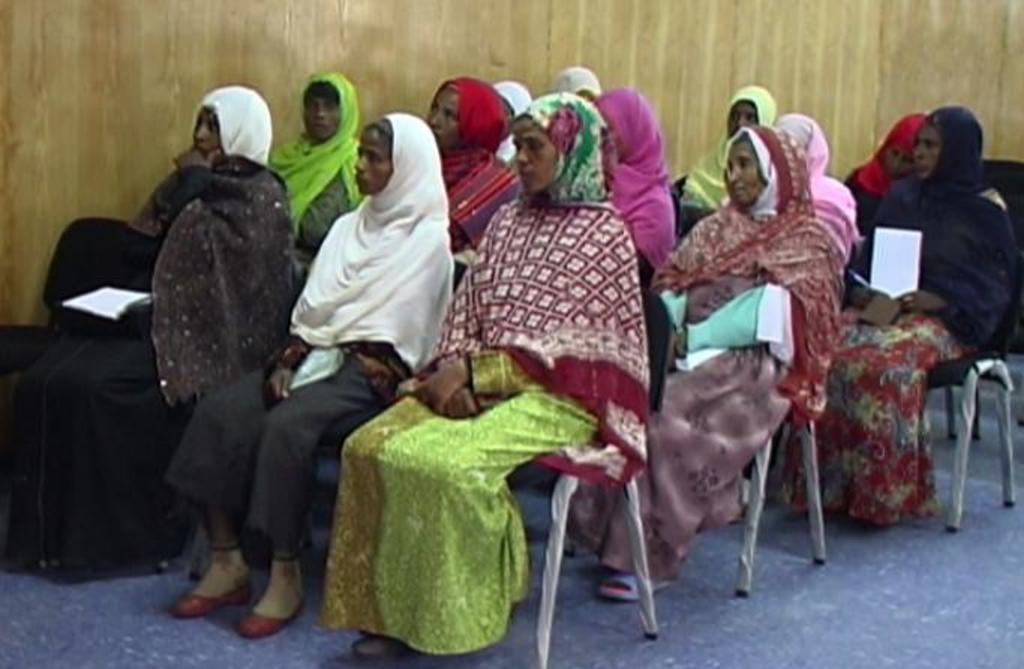Where is the setting of the image? The image is inside a room. What are the people in the image doing? There is a group of people sitting on chairs in the image. What color is the wall in the background of the image? There is a yellow color wall in the background of the image. What type of note is being passed around among the people in the image? There is no note being passed around among the people in the image; the people are simply sitting on chairs. What is the source of the surprise in the image? There is no surprise depicted in the image; it shows a group of people sitting on chairs in a room with a yellow wall in the background. 